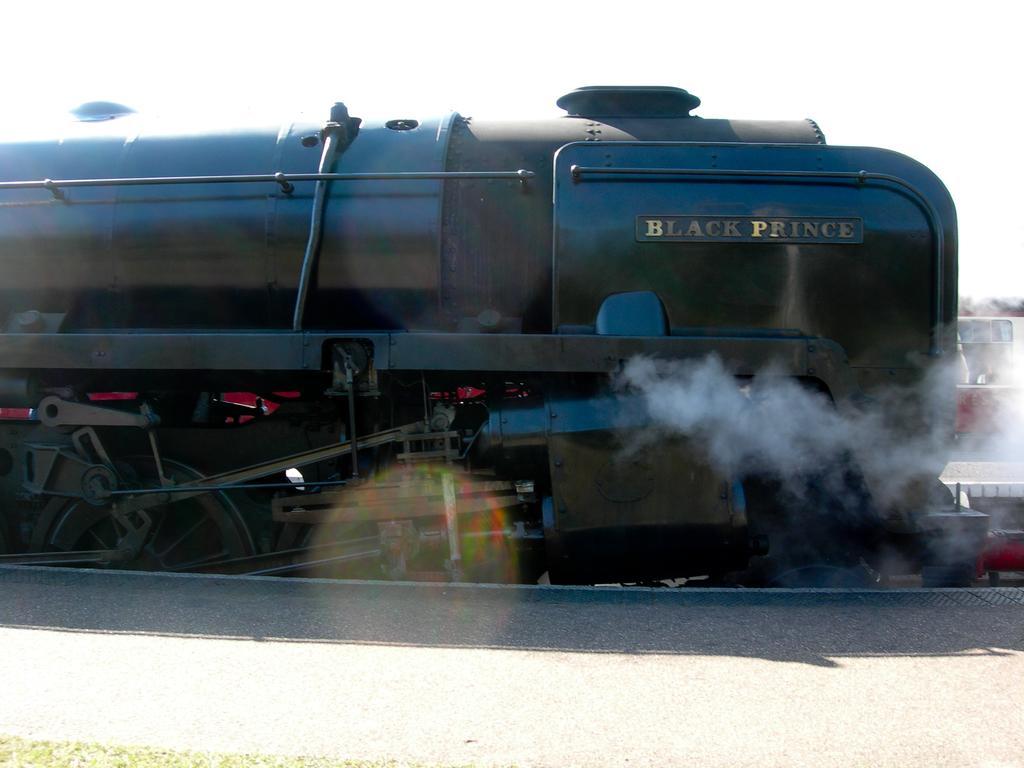Could you give a brief overview of what you see in this image? In this image I can see the platform and the train which is black in color on the track. I can see some smoke and in the background I can see another train and the sky. 